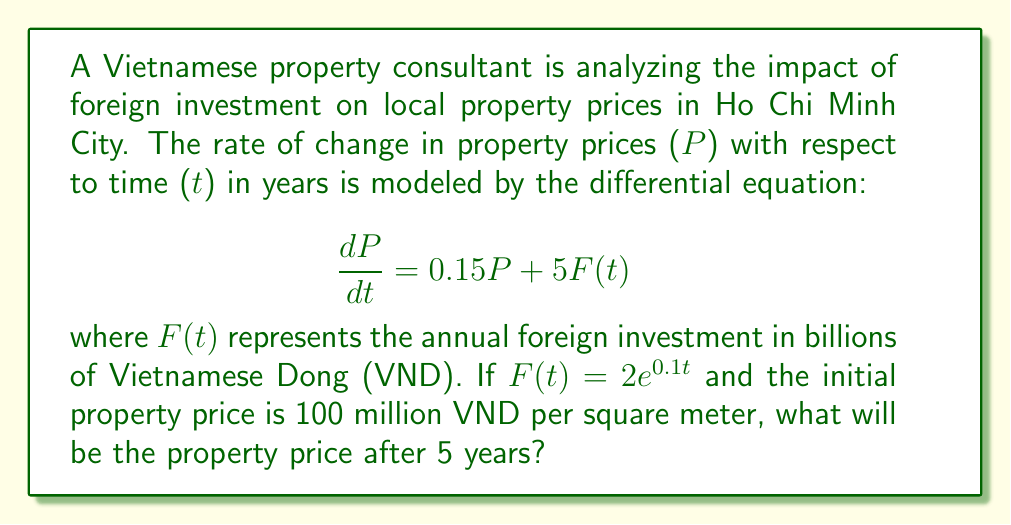Help me with this question. To solve this problem, we need to follow these steps:

1) First, we have a first-order linear differential equation:

   $$\frac{dP}{dt} = 0.15P + 5F(t)$$

2) We're given that F(t) = 2e^(0.1t), so we can substitute this:

   $$\frac{dP}{dt} = 0.15P + 5(2e^{0.1t}) = 0.15P + 10e^{0.1t}$$

3) This is a linear first-order differential equation of the form:

   $$\frac{dP}{dt} + P(-0.15) = 10e^{0.1t}$$

4) The integrating factor is:

   $$\mu(t) = e^{\int -0.15 dt} = e^{-0.15t}$$

5) Multiplying both sides by the integrating factor:

   $$e^{-0.15t}\frac{dP}{dt} + e^{-0.15t}P(-0.15) = 10e^{-0.15t}e^{0.1t} = 10e^{-0.05t}$$

6) The left side is now the derivative of Pe^(-0.15t), so we can write:

   $$\frac{d}{dt}[Pe^{-0.15t}] = 10e^{-0.05t}$$

7) Integrating both sides:

   $$Pe^{-0.15t} = -200e^{-0.05t} + C$$

8) Solving for P:

   $$P = -200e^{0.1t} + Ce^{0.15t}$$

9) Using the initial condition P(0) = 100, we can find C:

   $$100 = -200 + C$$
   $$C = 300$$

10) So our final solution is:

    $$P(t) = -200e^{0.1t} + 300e^{0.15t}$$

11) To find the price after 5 years, we evaluate P(5):

    $$P(5) = -200e^{0.1(5)} + 300e^{0.15(5)}$$
    $$= -200e^{0.5} + 300e^{0.75}$$
    $$\approx 478.56$$
Answer: The property price after 5 years will be approximately 478.56 million VND per square meter. 